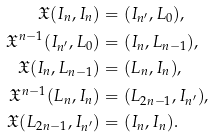Convert formula to latex. <formula><loc_0><loc_0><loc_500><loc_500>\mathfrak { X } ( I _ { n } , I _ { n } ) & = ( I _ { n ^ { \prime } } , L _ { 0 } ) , \\ \mathfrak { X } ^ { n - 1 } ( I _ { n ^ { \prime } } , L _ { 0 } ) & = ( I _ { n } , L _ { n - 1 } ) , \\ \mathfrak { X } ( I _ { n } , L _ { n - 1 } ) & = ( L _ { n } , I _ { n } ) , \\ \mathfrak { X } ^ { n - 1 } ( L _ { n } , I _ { n } ) & = ( L _ { 2 n - 1 } , I _ { n ^ { \prime } } ) , \\ \mathfrak { X } ( L _ { 2 n - 1 } , I _ { n ^ { \prime } } ) & = ( I _ { n } , I _ { n } ) .</formula> 